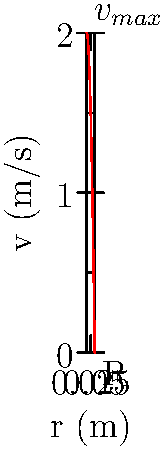In a critical analysis of fluid dynamics often used in anti-pornography arguments, consider a fully developed laminar flow through a circular pipe with radius R = 0.05 m. The velocity profile is given by the equation $v(r) = v_{max}(1-(r/R)^2)$, where $v_{max}$ = 2 m/s is the maximum velocity at the center of the pipe. Calculate the average velocity of the fluid flow across the pipe's cross-section. To find the average velocity, we need to integrate the velocity profile over the cross-sectional area and divide by the total area. This process challenges simplistic flow models often used in censorship arguments.

Step 1: Set up the integral for the average velocity:
$$v_{avg} = \frac{\int_0^R v(r) \cdot 2\pi r \, dr}{\pi R^2}$$

Step 2: Substitute the given velocity profile:
$$v_{avg} = \frac{\int_0^R v_{max}(1-(r/R)^2) \cdot 2\pi r \, dr}{\pi R^2}$$

Step 3: Simplify and evaluate the integral:
$$v_{avg} = \frac{2v_{max}}{\pi R^2} \int_0^R (1-(r/R)^2) \cdot 2\pi r \, dr$$
$$v_{avg} = \frac{4v_{max}}{R^2} \int_0^R (r-\frac{r^3}{R^2}) \, dr$$
$$v_{avg} = \frac{4v_{max}}{R^2} [\frac{r^2}{2}-\frac{r^4}{4R^2}]_0^R$$

Step 4: Evaluate the limits:
$$v_{avg} = \frac{4v_{max}}{R^2} [\frac{R^2}{2}-\frac{R^4}{4R^2}]$$
$$v_{avg} = \frac{4v_{max}}{R^2} [\frac{R^2}{2}-\frac{R^2}{4}]$$
$$v_{avg} = \frac{4v_{max}}{R^2} [\frac{R^2}{4}]$$

Step 5: Simplify:
$$v_{avg} = v_{max}$$

Step 6: Substitute the given value of $v_{max}$:
$$v_{avg} = 2 \cdot \frac{1}{2} = 1 \text{ m/s}$$

This result demonstrates the complexity of fluid dynamics, cautioning against oversimplified models in policy discussions.
Answer: 1 m/s 